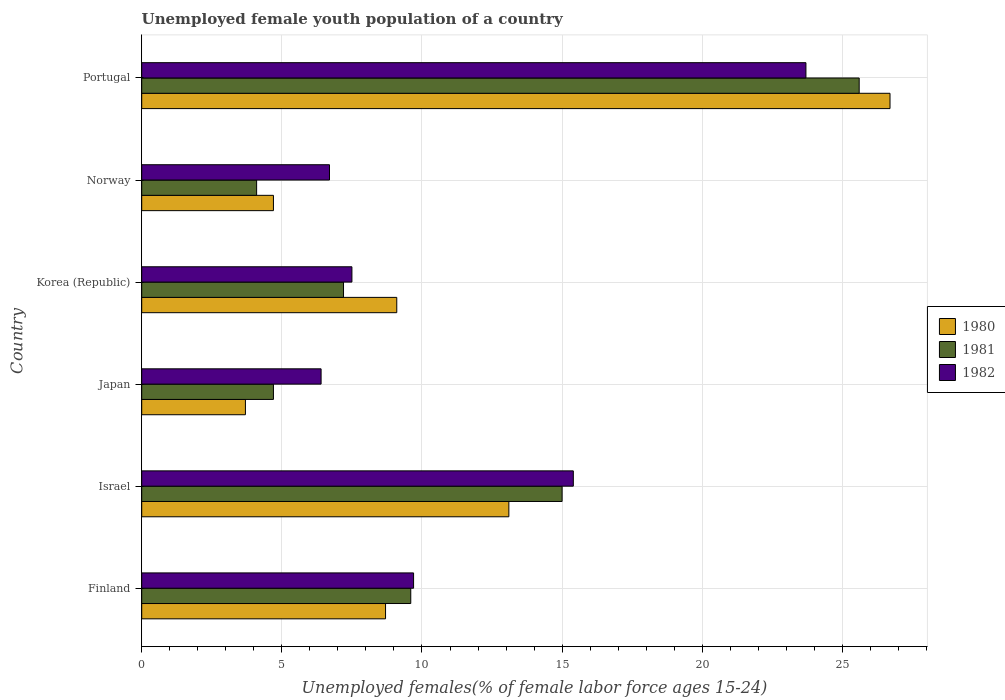How many groups of bars are there?
Offer a very short reply. 6. Are the number of bars per tick equal to the number of legend labels?
Your answer should be very brief. Yes. How many bars are there on the 6th tick from the bottom?
Offer a very short reply. 3. What is the label of the 1st group of bars from the top?
Offer a terse response. Portugal. In how many cases, is the number of bars for a given country not equal to the number of legend labels?
Ensure brevity in your answer.  0. What is the percentage of unemployed female youth population in 1980 in Finland?
Provide a succinct answer. 8.7. Across all countries, what is the maximum percentage of unemployed female youth population in 1982?
Ensure brevity in your answer.  23.7. Across all countries, what is the minimum percentage of unemployed female youth population in 1982?
Your answer should be compact. 6.4. In which country was the percentage of unemployed female youth population in 1980 maximum?
Ensure brevity in your answer.  Portugal. What is the total percentage of unemployed female youth population in 1982 in the graph?
Provide a short and direct response. 69.4. What is the difference between the percentage of unemployed female youth population in 1982 in Korea (Republic) and that in Norway?
Your answer should be very brief. 0.8. What is the difference between the percentage of unemployed female youth population in 1982 in Israel and the percentage of unemployed female youth population in 1981 in Japan?
Give a very brief answer. 10.7. What is the average percentage of unemployed female youth population in 1980 per country?
Give a very brief answer. 11. What is the difference between the percentage of unemployed female youth population in 1981 and percentage of unemployed female youth population in 1980 in Portugal?
Your answer should be compact. -1.1. In how many countries, is the percentage of unemployed female youth population in 1982 greater than 8 %?
Offer a terse response. 3. What is the ratio of the percentage of unemployed female youth population in 1981 in Finland to that in Norway?
Keep it short and to the point. 2.34. What is the difference between the highest and the second highest percentage of unemployed female youth population in 1981?
Give a very brief answer. 10.6. What is the difference between the highest and the lowest percentage of unemployed female youth population in 1980?
Give a very brief answer. 23. What does the 1st bar from the top in Portugal represents?
Provide a short and direct response. 1982. How many countries are there in the graph?
Your response must be concise. 6. What is the difference between two consecutive major ticks on the X-axis?
Offer a very short reply. 5. Does the graph contain grids?
Your answer should be very brief. Yes. How many legend labels are there?
Give a very brief answer. 3. How are the legend labels stacked?
Make the answer very short. Vertical. What is the title of the graph?
Your response must be concise. Unemployed female youth population of a country. Does "1966" appear as one of the legend labels in the graph?
Keep it short and to the point. No. What is the label or title of the X-axis?
Your response must be concise. Unemployed females(% of female labor force ages 15-24). What is the Unemployed females(% of female labor force ages 15-24) of 1980 in Finland?
Ensure brevity in your answer.  8.7. What is the Unemployed females(% of female labor force ages 15-24) in 1981 in Finland?
Offer a very short reply. 9.6. What is the Unemployed females(% of female labor force ages 15-24) of 1982 in Finland?
Give a very brief answer. 9.7. What is the Unemployed females(% of female labor force ages 15-24) of 1980 in Israel?
Your response must be concise. 13.1. What is the Unemployed females(% of female labor force ages 15-24) in 1982 in Israel?
Ensure brevity in your answer.  15.4. What is the Unemployed females(% of female labor force ages 15-24) in 1980 in Japan?
Make the answer very short. 3.7. What is the Unemployed females(% of female labor force ages 15-24) in 1981 in Japan?
Ensure brevity in your answer.  4.7. What is the Unemployed females(% of female labor force ages 15-24) in 1982 in Japan?
Provide a short and direct response. 6.4. What is the Unemployed females(% of female labor force ages 15-24) of 1980 in Korea (Republic)?
Offer a terse response. 9.1. What is the Unemployed females(% of female labor force ages 15-24) of 1981 in Korea (Republic)?
Ensure brevity in your answer.  7.2. What is the Unemployed females(% of female labor force ages 15-24) in 1982 in Korea (Republic)?
Give a very brief answer. 7.5. What is the Unemployed females(% of female labor force ages 15-24) of 1980 in Norway?
Offer a terse response. 4.7. What is the Unemployed females(% of female labor force ages 15-24) in 1981 in Norway?
Make the answer very short. 4.1. What is the Unemployed females(% of female labor force ages 15-24) in 1982 in Norway?
Your answer should be compact. 6.7. What is the Unemployed females(% of female labor force ages 15-24) of 1980 in Portugal?
Keep it short and to the point. 26.7. What is the Unemployed females(% of female labor force ages 15-24) in 1981 in Portugal?
Offer a very short reply. 25.6. What is the Unemployed females(% of female labor force ages 15-24) in 1982 in Portugal?
Your answer should be compact. 23.7. Across all countries, what is the maximum Unemployed females(% of female labor force ages 15-24) in 1980?
Your answer should be very brief. 26.7. Across all countries, what is the maximum Unemployed females(% of female labor force ages 15-24) of 1981?
Provide a short and direct response. 25.6. Across all countries, what is the maximum Unemployed females(% of female labor force ages 15-24) in 1982?
Give a very brief answer. 23.7. Across all countries, what is the minimum Unemployed females(% of female labor force ages 15-24) in 1980?
Offer a very short reply. 3.7. Across all countries, what is the minimum Unemployed females(% of female labor force ages 15-24) in 1981?
Your answer should be very brief. 4.1. Across all countries, what is the minimum Unemployed females(% of female labor force ages 15-24) of 1982?
Offer a very short reply. 6.4. What is the total Unemployed females(% of female labor force ages 15-24) of 1980 in the graph?
Your response must be concise. 66. What is the total Unemployed females(% of female labor force ages 15-24) in 1981 in the graph?
Your answer should be very brief. 66.2. What is the total Unemployed females(% of female labor force ages 15-24) in 1982 in the graph?
Your answer should be very brief. 69.4. What is the difference between the Unemployed females(% of female labor force ages 15-24) of 1981 in Finland and that in Israel?
Make the answer very short. -5.4. What is the difference between the Unemployed females(% of female labor force ages 15-24) in 1982 in Finland and that in Israel?
Offer a terse response. -5.7. What is the difference between the Unemployed females(% of female labor force ages 15-24) in 1980 in Finland and that in Japan?
Provide a succinct answer. 5. What is the difference between the Unemployed females(% of female labor force ages 15-24) in 1981 in Finland and that in Japan?
Ensure brevity in your answer.  4.9. What is the difference between the Unemployed females(% of female labor force ages 15-24) of 1981 in Finland and that in Korea (Republic)?
Offer a very short reply. 2.4. What is the difference between the Unemployed females(% of female labor force ages 15-24) of 1981 in Finland and that in Norway?
Give a very brief answer. 5.5. What is the difference between the Unemployed females(% of female labor force ages 15-24) in 1982 in Finland and that in Norway?
Ensure brevity in your answer.  3. What is the difference between the Unemployed females(% of female labor force ages 15-24) of 1981 in Finland and that in Portugal?
Make the answer very short. -16. What is the difference between the Unemployed females(% of female labor force ages 15-24) in 1982 in Finland and that in Portugal?
Give a very brief answer. -14. What is the difference between the Unemployed females(% of female labor force ages 15-24) of 1980 in Israel and that in Japan?
Offer a very short reply. 9.4. What is the difference between the Unemployed females(% of female labor force ages 15-24) of 1982 in Israel and that in Japan?
Give a very brief answer. 9. What is the difference between the Unemployed females(% of female labor force ages 15-24) in 1981 in Israel and that in Korea (Republic)?
Your answer should be very brief. 7.8. What is the difference between the Unemployed females(% of female labor force ages 15-24) in 1982 in Israel and that in Korea (Republic)?
Your answer should be very brief. 7.9. What is the difference between the Unemployed females(% of female labor force ages 15-24) of 1980 in Israel and that in Norway?
Your answer should be compact. 8.4. What is the difference between the Unemployed females(% of female labor force ages 15-24) of 1982 in Israel and that in Norway?
Give a very brief answer. 8.7. What is the difference between the Unemployed females(% of female labor force ages 15-24) of 1980 in Israel and that in Portugal?
Give a very brief answer. -13.6. What is the difference between the Unemployed females(% of female labor force ages 15-24) in 1982 in Israel and that in Portugal?
Your answer should be very brief. -8.3. What is the difference between the Unemployed females(% of female labor force ages 15-24) in 1980 in Japan and that in Korea (Republic)?
Make the answer very short. -5.4. What is the difference between the Unemployed females(% of female labor force ages 15-24) in 1981 in Japan and that in Korea (Republic)?
Give a very brief answer. -2.5. What is the difference between the Unemployed females(% of female labor force ages 15-24) in 1982 in Japan and that in Korea (Republic)?
Offer a very short reply. -1.1. What is the difference between the Unemployed females(% of female labor force ages 15-24) of 1981 in Japan and that in Norway?
Offer a terse response. 0.6. What is the difference between the Unemployed females(% of female labor force ages 15-24) in 1982 in Japan and that in Norway?
Your answer should be very brief. -0.3. What is the difference between the Unemployed females(% of female labor force ages 15-24) of 1980 in Japan and that in Portugal?
Ensure brevity in your answer.  -23. What is the difference between the Unemployed females(% of female labor force ages 15-24) of 1981 in Japan and that in Portugal?
Your response must be concise. -20.9. What is the difference between the Unemployed females(% of female labor force ages 15-24) of 1982 in Japan and that in Portugal?
Your response must be concise. -17.3. What is the difference between the Unemployed females(% of female labor force ages 15-24) in 1980 in Korea (Republic) and that in Norway?
Your response must be concise. 4.4. What is the difference between the Unemployed females(% of female labor force ages 15-24) in 1981 in Korea (Republic) and that in Norway?
Your answer should be very brief. 3.1. What is the difference between the Unemployed females(% of female labor force ages 15-24) in 1980 in Korea (Republic) and that in Portugal?
Offer a very short reply. -17.6. What is the difference between the Unemployed females(% of female labor force ages 15-24) in 1981 in Korea (Republic) and that in Portugal?
Offer a terse response. -18.4. What is the difference between the Unemployed females(% of female labor force ages 15-24) of 1982 in Korea (Republic) and that in Portugal?
Provide a short and direct response. -16.2. What is the difference between the Unemployed females(% of female labor force ages 15-24) of 1980 in Norway and that in Portugal?
Make the answer very short. -22. What is the difference between the Unemployed females(% of female labor force ages 15-24) in 1981 in Norway and that in Portugal?
Your answer should be compact. -21.5. What is the difference between the Unemployed females(% of female labor force ages 15-24) in 1981 in Finland and the Unemployed females(% of female labor force ages 15-24) in 1982 in Israel?
Give a very brief answer. -5.8. What is the difference between the Unemployed females(% of female labor force ages 15-24) of 1980 in Finland and the Unemployed females(% of female labor force ages 15-24) of 1982 in Japan?
Your response must be concise. 2.3. What is the difference between the Unemployed females(% of female labor force ages 15-24) in 1980 in Finland and the Unemployed females(% of female labor force ages 15-24) in 1981 in Norway?
Give a very brief answer. 4.6. What is the difference between the Unemployed females(% of female labor force ages 15-24) in 1981 in Finland and the Unemployed females(% of female labor force ages 15-24) in 1982 in Norway?
Make the answer very short. 2.9. What is the difference between the Unemployed females(% of female labor force ages 15-24) in 1980 in Finland and the Unemployed females(% of female labor force ages 15-24) in 1981 in Portugal?
Offer a very short reply. -16.9. What is the difference between the Unemployed females(% of female labor force ages 15-24) of 1980 in Finland and the Unemployed females(% of female labor force ages 15-24) of 1982 in Portugal?
Provide a short and direct response. -15. What is the difference between the Unemployed females(% of female labor force ages 15-24) in 1981 in Finland and the Unemployed females(% of female labor force ages 15-24) in 1982 in Portugal?
Make the answer very short. -14.1. What is the difference between the Unemployed females(% of female labor force ages 15-24) in 1980 in Israel and the Unemployed females(% of female labor force ages 15-24) in 1981 in Japan?
Your response must be concise. 8.4. What is the difference between the Unemployed females(% of female labor force ages 15-24) in 1980 in Israel and the Unemployed females(% of female labor force ages 15-24) in 1982 in Japan?
Provide a succinct answer. 6.7. What is the difference between the Unemployed females(% of female labor force ages 15-24) of 1980 in Israel and the Unemployed females(% of female labor force ages 15-24) of 1981 in Korea (Republic)?
Offer a very short reply. 5.9. What is the difference between the Unemployed females(% of female labor force ages 15-24) in 1980 in Israel and the Unemployed females(% of female labor force ages 15-24) in 1982 in Norway?
Provide a succinct answer. 6.4. What is the difference between the Unemployed females(% of female labor force ages 15-24) of 1981 in Israel and the Unemployed females(% of female labor force ages 15-24) of 1982 in Norway?
Keep it short and to the point. 8.3. What is the difference between the Unemployed females(% of female labor force ages 15-24) of 1980 in Israel and the Unemployed females(% of female labor force ages 15-24) of 1981 in Portugal?
Keep it short and to the point. -12.5. What is the difference between the Unemployed females(% of female labor force ages 15-24) in 1981 in Israel and the Unemployed females(% of female labor force ages 15-24) in 1982 in Portugal?
Ensure brevity in your answer.  -8.7. What is the difference between the Unemployed females(% of female labor force ages 15-24) in 1980 in Japan and the Unemployed females(% of female labor force ages 15-24) in 1981 in Korea (Republic)?
Your answer should be compact. -3.5. What is the difference between the Unemployed females(% of female labor force ages 15-24) of 1981 in Japan and the Unemployed females(% of female labor force ages 15-24) of 1982 in Korea (Republic)?
Offer a very short reply. -2.8. What is the difference between the Unemployed females(% of female labor force ages 15-24) in 1980 in Japan and the Unemployed females(% of female labor force ages 15-24) in 1981 in Norway?
Your answer should be compact. -0.4. What is the difference between the Unemployed females(% of female labor force ages 15-24) in 1980 in Japan and the Unemployed females(% of female labor force ages 15-24) in 1982 in Norway?
Your answer should be very brief. -3. What is the difference between the Unemployed females(% of female labor force ages 15-24) of 1981 in Japan and the Unemployed females(% of female labor force ages 15-24) of 1982 in Norway?
Your answer should be compact. -2. What is the difference between the Unemployed females(% of female labor force ages 15-24) of 1980 in Japan and the Unemployed females(% of female labor force ages 15-24) of 1981 in Portugal?
Keep it short and to the point. -21.9. What is the difference between the Unemployed females(% of female labor force ages 15-24) of 1980 in Japan and the Unemployed females(% of female labor force ages 15-24) of 1982 in Portugal?
Offer a terse response. -20. What is the difference between the Unemployed females(% of female labor force ages 15-24) of 1981 in Japan and the Unemployed females(% of female labor force ages 15-24) of 1982 in Portugal?
Your answer should be very brief. -19. What is the difference between the Unemployed females(% of female labor force ages 15-24) in 1980 in Korea (Republic) and the Unemployed females(% of female labor force ages 15-24) in 1981 in Norway?
Make the answer very short. 5. What is the difference between the Unemployed females(% of female labor force ages 15-24) of 1980 in Korea (Republic) and the Unemployed females(% of female labor force ages 15-24) of 1982 in Norway?
Your response must be concise. 2.4. What is the difference between the Unemployed females(% of female labor force ages 15-24) of 1980 in Korea (Republic) and the Unemployed females(% of female labor force ages 15-24) of 1981 in Portugal?
Provide a short and direct response. -16.5. What is the difference between the Unemployed females(% of female labor force ages 15-24) in 1980 in Korea (Republic) and the Unemployed females(% of female labor force ages 15-24) in 1982 in Portugal?
Provide a short and direct response. -14.6. What is the difference between the Unemployed females(% of female labor force ages 15-24) of 1981 in Korea (Republic) and the Unemployed females(% of female labor force ages 15-24) of 1982 in Portugal?
Your answer should be very brief. -16.5. What is the difference between the Unemployed females(% of female labor force ages 15-24) of 1980 in Norway and the Unemployed females(% of female labor force ages 15-24) of 1981 in Portugal?
Give a very brief answer. -20.9. What is the difference between the Unemployed females(% of female labor force ages 15-24) of 1980 in Norway and the Unemployed females(% of female labor force ages 15-24) of 1982 in Portugal?
Make the answer very short. -19. What is the difference between the Unemployed females(% of female labor force ages 15-24) in 1981 in Norway and the Unemployed females(% of female labor force ages 15-24) in 1982 in Portugal?
Ensure brevity in your answer.  -19.6. What is the average Unemployed females(% of female labor force ages 15-24) in 1980 per country?
Your answer should be compact. 11. What is the average Unemployed females(% of female labor force ages 15-24) of 1981 per country?
Keep it short and to the point. 11.03. What is the average Unemployed females(% of female labor force ages 15-24) in 1982 per country?
Keep it short and to the point. 11.57. What is the difference between the Unemployed females(% of female labor force ages 15-24) of 1980 and Unemployed females(% of female labor force ages 15-24) of 1981 in Finland?
Provide a succinct answer. -0.9. What is the difference between the Unemployed females(% of female labor force ages 15-24) of 1980 and Unemployed females(% of female labor force ages 15-24) of 1982 in Finland?
Offer a very short reply. -1. What is the difference between the Unemployed females(% of female labor force ages 15-24) in 1981 and Unemployed females(% of female labor force ages 15-24) in 1982 in Finland?
Give a very brief answer. -0.1. What is the difference between the Unemployed females(% of female labor force ages 15-24) of 1980 and Unemployed females(% of female labor force ages 15-24) of 1982 in Japan?
Provide a short and direct response. -2.7. What is the difference between the Unemployed females(% of female labor force ages 15-24) in 1980 and Unemployed females(% of female labor force ages 15-24) in 1981 in Korea (Republic)?
Offer a terse response. 1.9. What is the difference between the Unemployed females(% of female labor force ages 15-24) of 1980 and Unemployed females(% of female labor force ages 15-24) of 1982 in Korea (Republic)?
Your answer should be compact. 1.6. What is the difference between the Unemployed females(% of female labor force ages 15-24) in 1981 and Unemployed females(% of female labor force ages 15-24) in 1982 in Korea (Republic)?
Ensure brevity in your answer.  -0.3. What is the difference between the Unemployed females(% of female labor force ages 15-24) in 1980 and Unemployed females(% of female labor force ages 15-24) in 1981 in Norway?
Keep it short and to the point. 0.6. What is the difference between the Unemployed females(% of female labor force ages 15-24) of 1980 and Unemployed females(% of female labor force ages 15-24) of 1981 in Portugal?
Keep it short and to the point. 1.1. What is the difference between the Unemployed females(% of female labor force ages 15-24) of 1981 and Unemployed females(% of female labor force ages 15-24) of 1982 in Portugal?
Keep it short and to the point. 1.9. What is the ratio of the Unemployed females(% of female labor force ages 15-24) in 1980 in Finland to that in Israel?
Provide a succinct answer. 0.66. What is the ratio of the Unemployed females(% of female labor force ages 15-24) of 1981 in Finland to that in Israel?
Give a very brief answer. 0.64. What is the ratio of the Unemployed females(% of female labor force ages 15-24) in 1982 in Finland to that in Israel?
Keep it short and to the point. 0.63. What is the ratio of the Unemployed females(% of female labor force ages 15-24) of 1980 in Finland to that in Japan?
Provide a short and direct response. 2.35. What is the ratio of the Unemployed females(% of female labor force ages 15-24) in 1981 in Finland to that in Japan?
Keep it short and to the point. 2.04. What is the ratio of the Unemployed females(% of female labor force ages 15-24) of 1982 in Finland to that in Japan?
Provide a short and direct response. 1.52. What is the ratio of the Unemployed females(% of female labor force ages 15-24) in 1980 in Finland to that in Korea (Republic)?
Offer a very short reply. 0.96. What is the ratio of the Unemployed females(% of female labor force ages 15-24) in 1981 in Finland to that in Korea (Republic)?
Your answer should be very brief. 1.33. What is the ratio of the Unemployed females(% of female labor force ages 15-24) of 1982 in Finland to that in Korea (Republic)?
Offer a very short reply. 1.29. What is the ratio of the Unemployed females(% of female labor force ages 15-24) of 1980 in Finland to that in Norway?
Your answer should be compact. 1.85. What is the ratio of the Unemployed females(% of female labor force ages 15-24) of 1981 in Finland to that in Norway?
Ensure brevity in your answer.  2.34. What is the ratio of the Unemployed females(% of female labor force ages 15-24) in 1982 in Finland to that in Norway?
Offer a terse response. 1.45. What is the ratio of the Unemployed females(% of female labor force ages 15-24) of 1980 in Finland to that in Portugal?
Your response must be concise. 0.33. What is the ratio of the Unemployed females(% of female labor force ages 15-24) in 1981 in Finland to that in Portugal?
Keep it short and to the point. 0.38. What is the ratio of the Unemployed females(% of female labor force ages 15-24) in 1982 in Finland to that in Portugal?
Provide a short and direct response. 0.41. What is the ratio of the Unemployed females(% of female labor force ages 15-24) of 1980 in Israel to that in Japan?
Offer a very short reply. 3.54. What is the ratio of the Unemployed females(% of female labor force ages 15-24) in 1981 in Israel to that in Japan?
Offer a terse response. 3.19. What is the ratio of the Unemployed females(% of female labor force ages 15-24) of 1982 in Israel to that in Japan?
Your answer should be very brief. 2.41. What is the ratio of the Unemployed females(% of female labor force ages 15-24) of 1980 in Israel to that in Korea (Republic)?
Your answer should be very brief. 1.44. What is the ratio of the Unemployed females(% of female labor force ages 15-24) of 1981 in Israel to that in Korea (Republic)?
Offer a terse response. 2.08. What is the ratio of the Unemployed females(% of female labor force ages 15-24) of 1982 in Israel to that in Korea (Republic)?
Your answer should be very brief. 2.05. What is the ratio of the Unemployed females(% of female labor force ages 15-24) of 1980 in Israel to that in Norway?
Provide a succinct answer. 2.79. What is the ratio of the Unemployed females(% of female labor force ages 15-24) in 1981 in Israel to that in Norway?
Make the answer very short. 3.66. What is the ratio of the Unemployed females(% of female labor force ages 15-24) in 1982 in Israel to that in Norway?
Offer a terse response. 2.3. What is the ratio of the Unemployed females(% of female labor force ages 15-24) of 1980 in Israel to that in Portugal?
Ensure brevity in your answer.  0.49. What is the ratio of the Unemployed females(% of female labor force ages 15-24) of 1981 in Israel to that in Portugal?
Provide a short and direct response. 0.59. What is the ratio of the Unemployed females(% of female labor force ages 15-24) in 1982 in Israel to that in Portugal?
Offer a very short reply. 0.65. What is the ratio of the Unemployed females(% of female labor force ages 15-24) of 1980 in Japan to that in Korea (Republic)?
Your response must be concise. 0.41. What is the ratio of the Unemployed females(% of female labor force ages 15-24) of 1981 in Japan to that in Korea (Republic)?
Make the answer very short. 0.65. What is the ratio of the Unemployed females(% of female labor force ages 15-24) of 1982 in Japan to that in Korea (Republic)?
Provide a short and direct response. 0.85. What is the ratio of the Unemployed females(% of female labor force ages 15-24) of 1980 in Japan to that in Norway?
Make the answer very short. 0.79. What is the ratio of the Unemployed females(% of female labor force ages 15-24) in 1981 in Japan to that in Norway?
Make the answer very short. 1.15. What is the ratio of the Unemployed females(% of female labor force ages 15-24) of 1982 in Japan to that in Norway?
Ensure brevity in your answer.  0.96. What is the ratio of the Unemployed females(% of female labor force ages 15-24) in 1980 in Japan to that in Portugal?
Your answer should be compact. 0.14. What is the ratio of the Unemployed females(% of female labor force ages 15-24) of 1981 in Japan to that in Portugal?
Make the answer very short. 0.18. What is the ratio of the Unemployed females(% of female labor force ages 15-24) of 1982 in Japan to that in Portugal?
Offer a very short reply. 0.27. What is the ratio of the Unemployed females(% of female labor force ages 15-24) of 1980 in Korea (Republic) to that in Norway?
Offer a very short reply. 1.94. What is the ratio of the Unemployed females(% of female labor force ages 15-24) in 1981 in Korea (Republic) to that in Norway?
Your response must be concise. 1.76. What is the ratio of the Unemployed females(% of female labor force ages 15-24) in 1982 in Korea (Republic) to that in Norway?
Provide a succinct answer. 1.12. What is the ratio of the Unemployed females(% of female labor force ages 15-24) in 1980 in Korea (Republic) to that in Portugal?
Give a very brief answer. 0.34. What is the ratio of the Unemployed females(% of female labor force ages 15-24) in 1981 in Korea (Republic) to that in Portugal?
Provide a short and direct response. 0.28. What is the ratio of the Unemployed females(% of female labor force ages 15-24) of 1982 in Korea (Republic) to that in Portugal?
Provide a succinct answer. 0.32. What is the ratio of the Unemployed females(% of female labor force ages 15-24) of 1980 in Norway to that in Portugal?
Your answer should be compact. 0.18. What is the ratio of the Unemployed females(% of female labor force ages 15-24) of 1981 in Norway to that in Portugal?
Provide a succinct answer. 0.16. What is the ratio of the Unemployed females(% of female labor force ages 15-24) in 1982 in Norway to that in Portugal?
Ensure brevity in your answer.  0.28. 